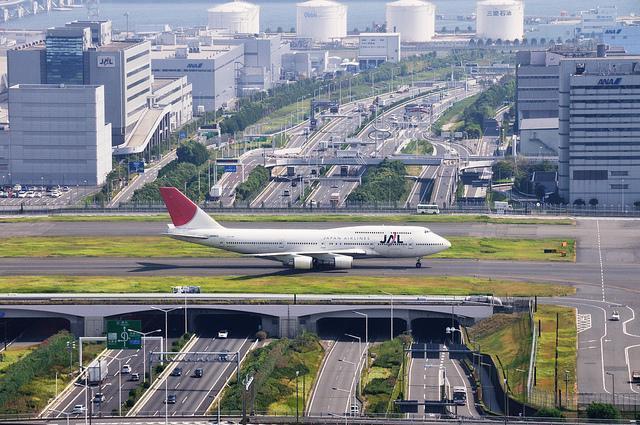What is the large vehicle getting ready to do?
Choose the correct response and explain in the format: 'Answer: answer
Rationale: rationale.'
Options: Fire missiles, race cars, race camels, fly. Answer: fly.
Rationale: This is an airliner What vehicle is the largest shown?
Indicate the correct choice and explain in the format: 'Answer: answer
Rationale: rationale.'
Options: Airplane, buggy, tank, elephant. Answer: airplane.
Rationale: The plane is huge and much bigger than anything else. 